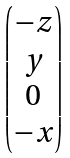<formula> <loc_0><loc_0><loc_500><loc_500>\begin{pmatrix} - z \\ y \\ 0 \\ - x \end{pmatrix}</formula> 